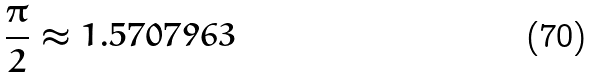<formula> <loc_0><loc_0><loc_500><loc_500>\frac { \pi } { 2 } \approx 1 . 5 7 0 7 9 6 3</formula> 